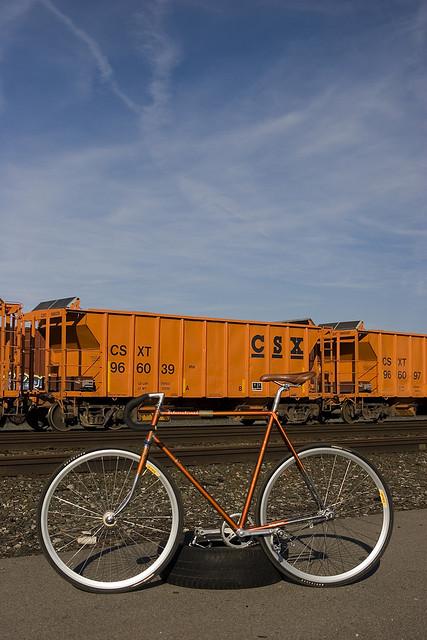How many methods of transportation are shown?
Give a very brief answer. 2. Does the color of the bike match the train?
Keep it brief. Yes. Is the sun in the photo?
Give a very brief answer. No. 